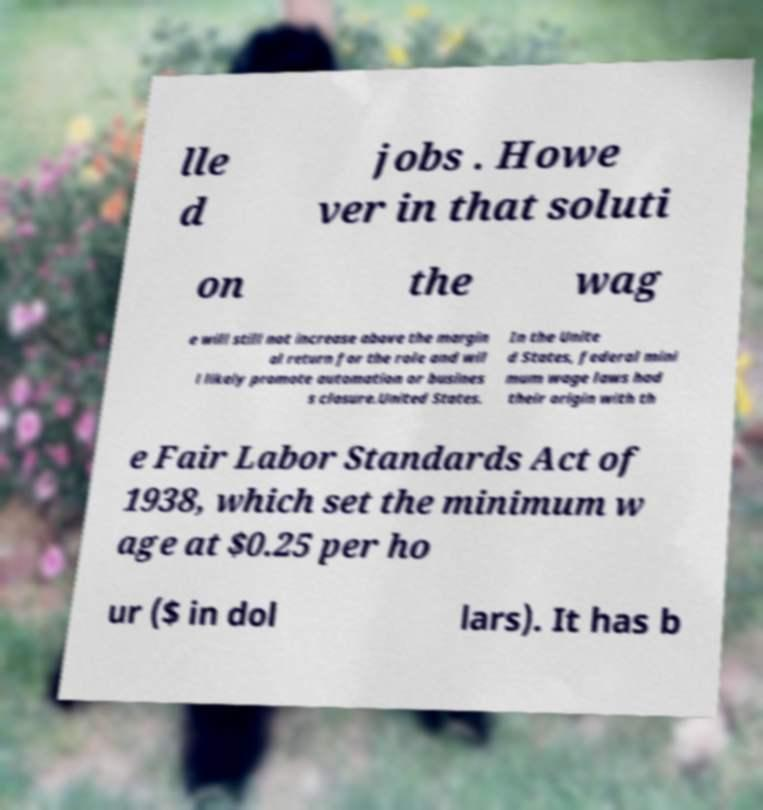I need the written content from this picture converted into text. Can you do that? lle d jobs . Howe ver in that soluti on the wag e will still not increase above the margin al return for the role and wil l likely promote automation or busines s closure.United States. In the Unite d States, federal mini mum wage laws had their origin with th e Fair Labor Standards Act of 1938, which set the minimum w age at $0.25 per ho ur ($ in dol lars). It has b 